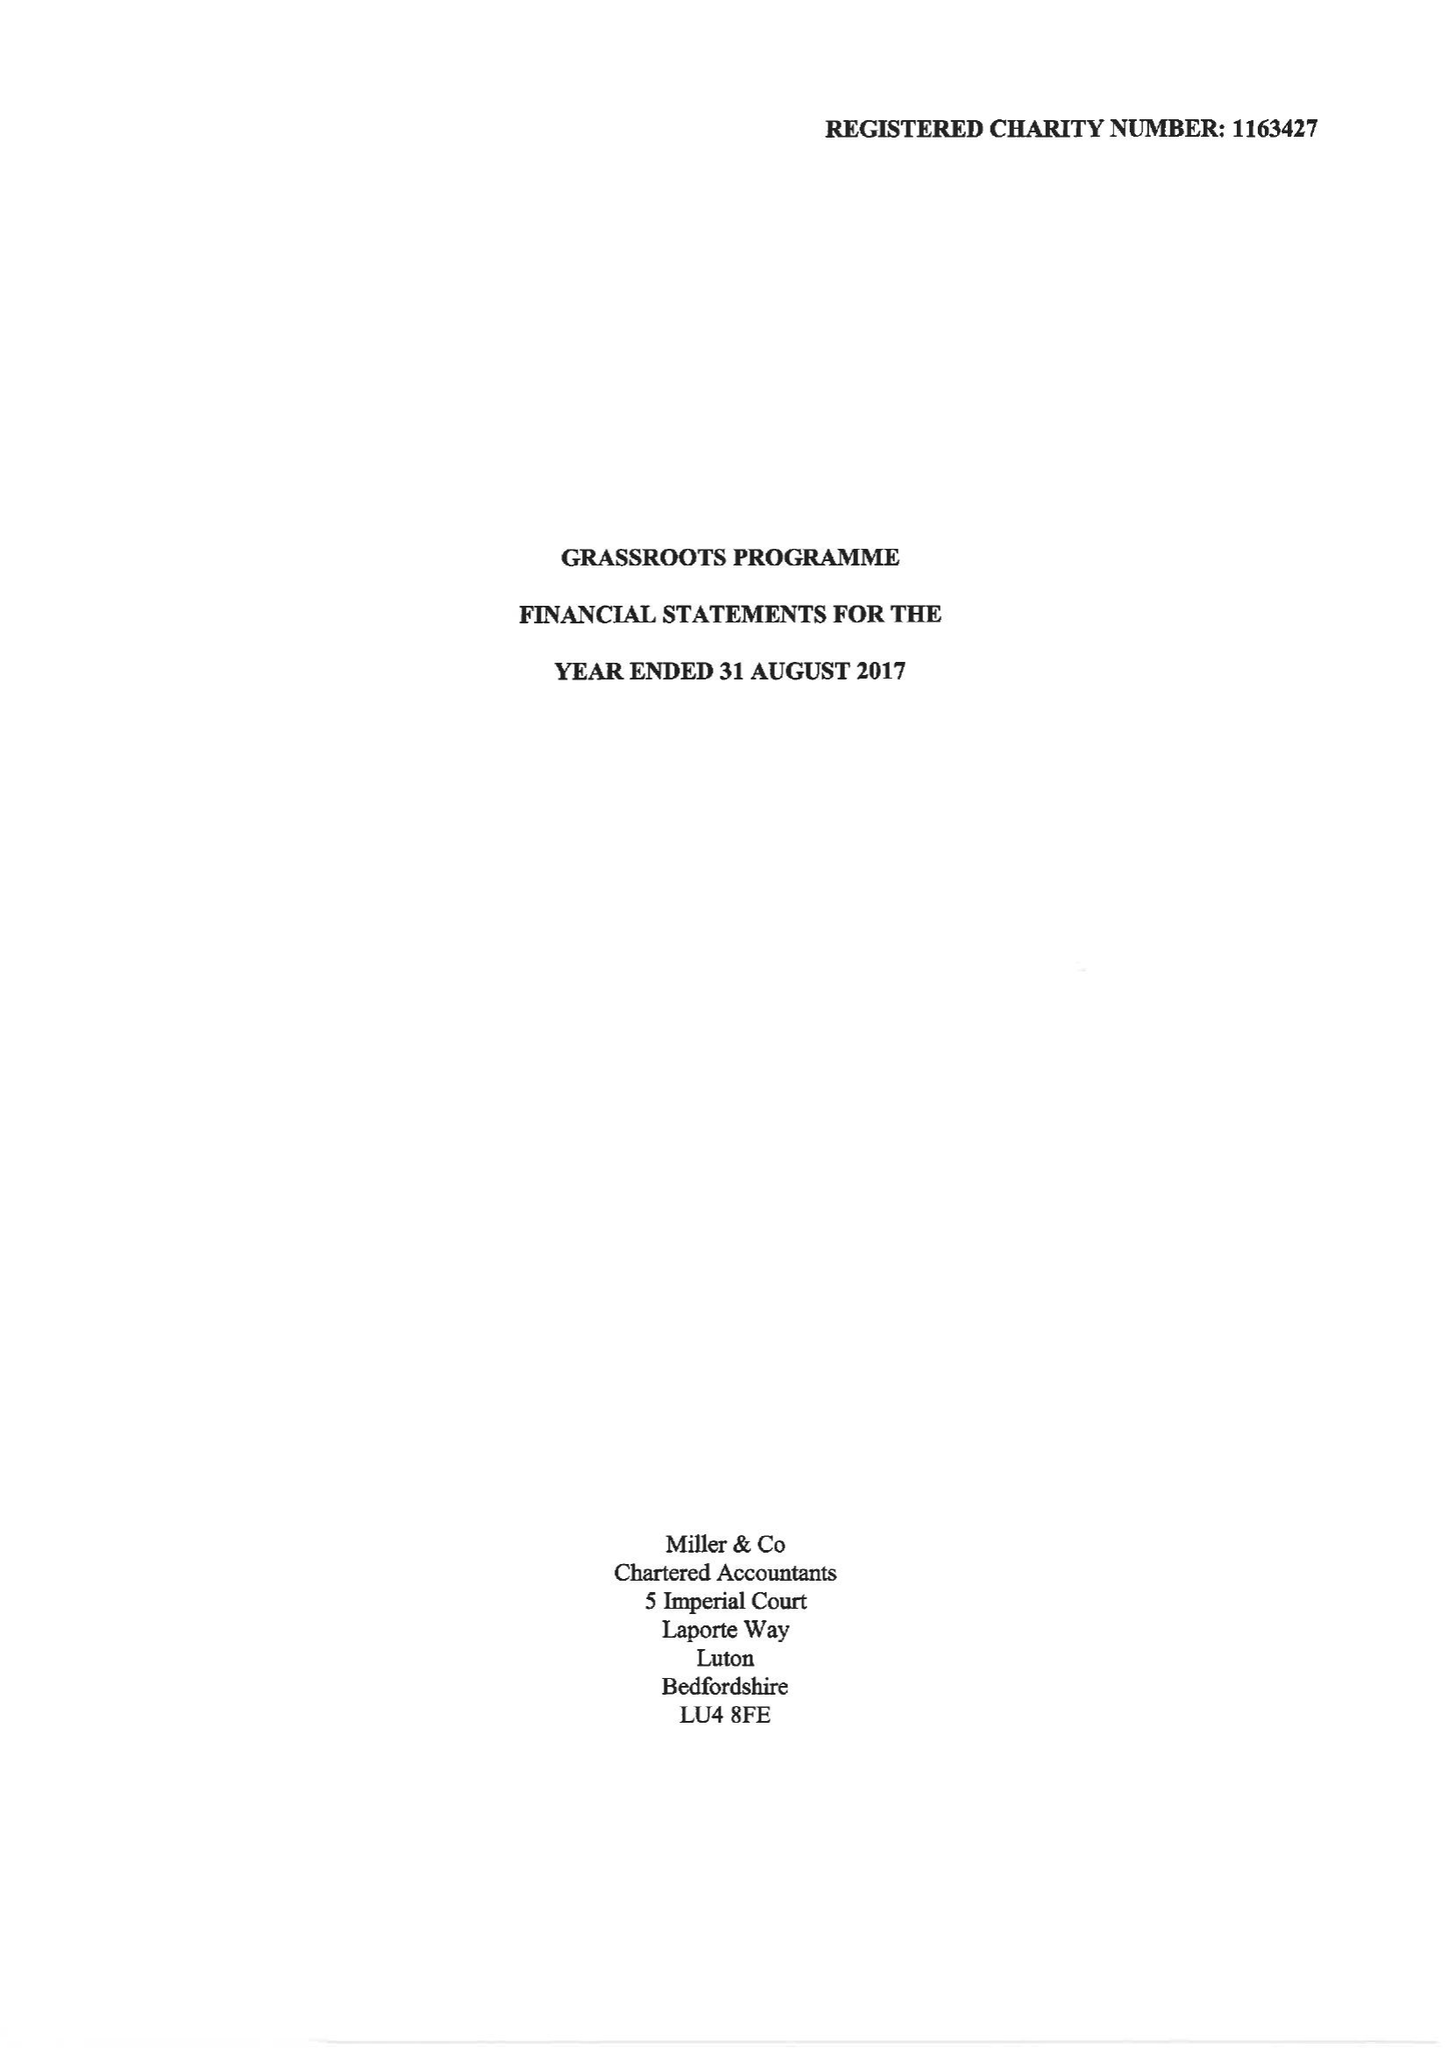What is the value for the address__post_town?
Answer the question using a single word or phrase. LUTON 